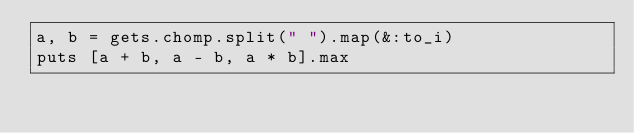<code> <loc_0><loc_0><loc_500><loc_500><_Ruby_>a, b = gets.chomp.split(" ").map(&:to_i)
puts [a + b, a - b, a * b].max</code> 